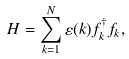<formula> <loc_0><loc_0><loc_500><loc_500>H = \sum _ { k = 1 } ^ { N } \varepsilon ( k ) f _ { k } ^ { \dagger } f _ { k } ,</formula> 